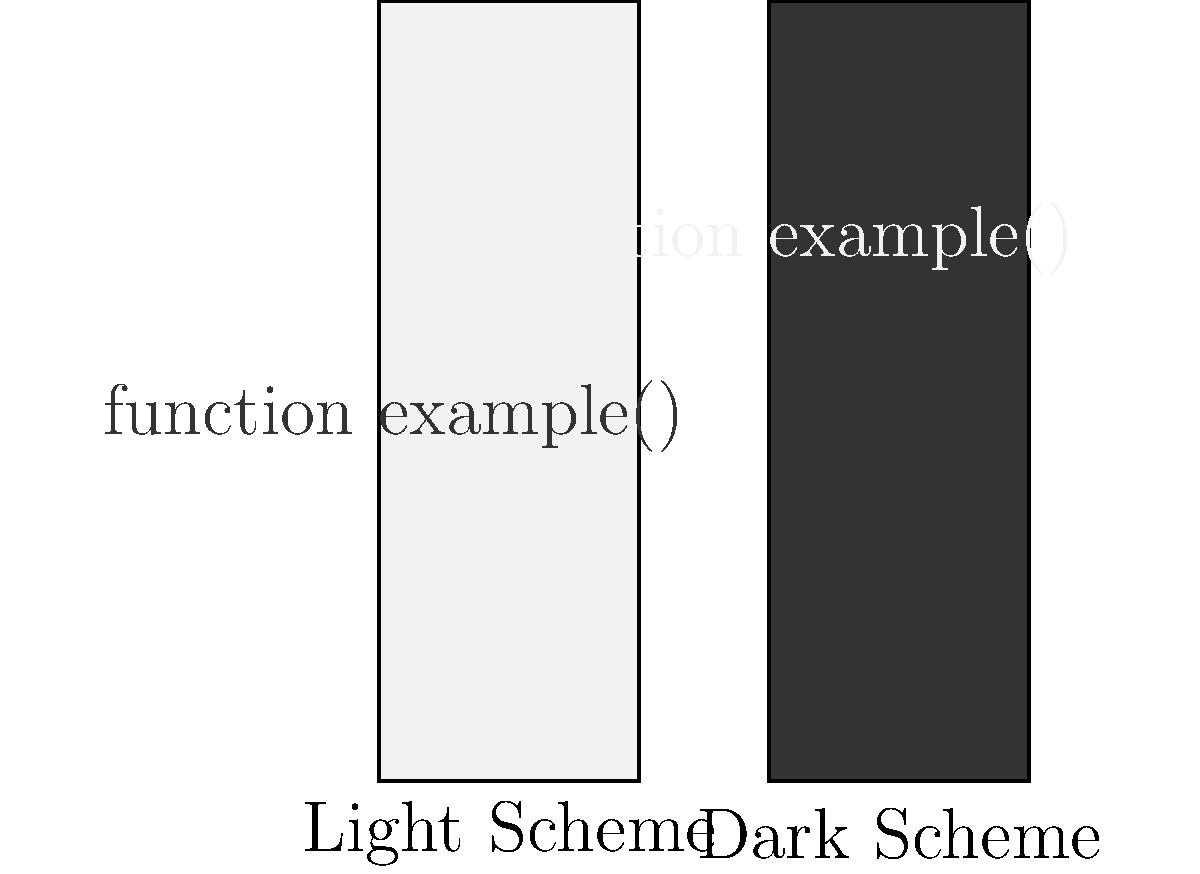In PhpStorm, which color scheme option is generally recommended for reducing eye strain during long coding sessions, especially in low-light environments? To determine the best color scheme for reducing eye strain during long coding sessions, especially in low-light environments, consider the following factors:

1. Contrast: High contrast between text and background can cause eye strain over time.
2. Brightness: Overly bright backgrounds can be harsh on the eyes, particularly in low-light conditions.
3. Color temperature: Warmer colors are generally easier on the eyes in low-light environments.

Analyzing the two color schemes presented in the image:

1. Light Scheme:
   - High contrast between dark text and light background
   - Bright background which can be harsh in low-light conditions
   - May cause more eye strain in dimly lit environments

2. Dark Scheme:
   - Softer contrast between light text and dark background
   - Darker background which is less harsh on the eyes in low-light conditions
   - Reduced overall brightness, which is beneficial for extended use

Given these considerations, the dark color scheme is generally recommended for reducing eye strain during long coding sessions, especially in low-light environments. It provides a more comfortable viewing experience by reducing the overall brightness and creating a softer contrast between text and background.

In PhpStorm, you can easily switch between light and dark themes by going to Settings/Preferences > Appearance & Behavior > Appearance and selecting the appropriate theme.
Answer: Dark Scheme 